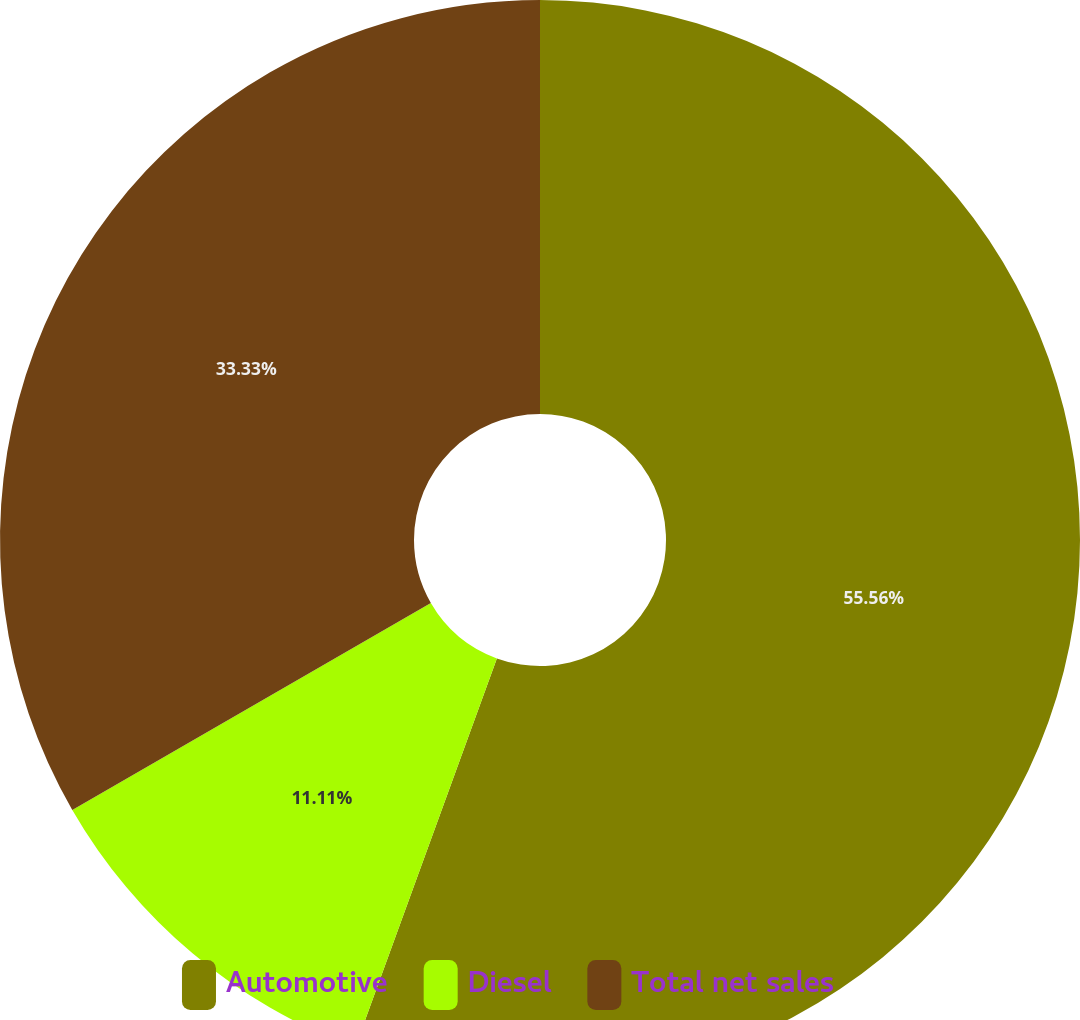<chart> <loc_0><loc_0><loc_500><loc_500><pie_chart><fcel>Automotive<fcel>Diesel<fcel>Total net sales<nl><fcel>55.56%<fcel>11.11%<fcel>33.33%<nl></chart> 